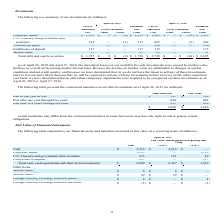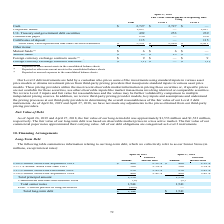According to Netapp's financial document, What does the table show? summarizes our financial assets and liabilities measured at fair value on a recurring basis. The document states: "The following table summarizes our financial assets and liabilities measured at fair value on a recurring basis (in millions):..." Also, What was the fair value measurements using Level 2 for Corporate Bonds? According to the financial document, 1,353 (in millions). The relevant text states: "Corporate bonds 1,353 — 1,353..." Also, What were the total cash, cash equivalents and short-term investments? According to the financial document, 3,899 (in millions). The relevant text states: "sh, cash equivalents and short-term investments $ 3,899 $ 2,347 $ 1,552..." Also, can you calculate: What was the difference in the fair value for U.S. Treasury and government debt securities between Level 1 and Level 2? Based on the calculation: 131-82, the result is 49 (in millions). This is based on the information: ". Treasury and government debt securities 213 131 82 U.S. Treasury and government debt securities 213 131 82..." The key data points involved are: 131, 82. Also, can you calculate: What was the fair value of Level 2 Total cash, cash equivalents and short-term investments as a percentage of the total cash, cash equivalents and short-term investments? Based on the calculation: 1,552/3,899, the result is 39.81 (percentage). This is based on the information: "ents and short-term investments $ 3,899 $ 2,347 $ 1,552 sh, cash equivalents and short-term investments $ 3,899 $ 2,347 $ 1,552..." The key data points involved are: 1,552, 3,899. Also, can you calculate: What was the difference between the Total cash, cash equivalents and short-term investments for Level 1 and Level 2? Based on the calculation: 2,347-1,552, the result is 795 (in millions). This is based on the information: "ents and short-term investments $ 3,899 $ 2,347 $ 1,552 equivalents and short-term investments $ 3,899 $ 2,347 $ 1,552..." The key data points involved are: 1,552, 2,347. 